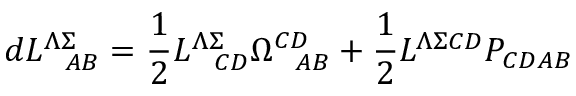<formula> <loc_0><loc_0><loc_500><loc_500>d L _ { \ \ A B } ^ { \Lambda \Sigma } = { \frac { 1 } { 2 } } L _ { \ \ C D } ^ { \Lambda \Sigma } \Omega _ { \ \ A B } ^ { C D } + { \frac { 1 } { 2 } } L ^ { \Lambda \Sigma C D } P _ { C D A B }</formula> 